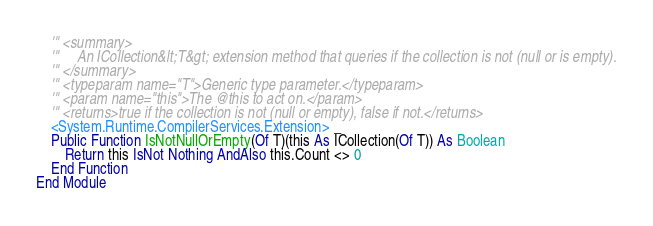<code> <loc_0><loc_0><loc_500><loc_500><_VisualBasic_>	''' <summary>
	'''     An ICollection&lt;T&gt; extension method that queries if the collection is not (null or is empty).
	''' </summary>
	''' <typeparam name="T">Generic type parameter.</typeparam>
	''' <param name="this">The @this to act on.</param>
	''' <returns>true if the collection is not (null or empty), false if not.</returns>
	<System.Runtime.CompilerServices.Extension> _
	Public Function IsNotNullOrEmpty(Of T)(this As ICollection(Of T)) As Boolean
		Return this IsNot Nothing AndAlso this.Count <> 0
	End Function
End Module


</code> 